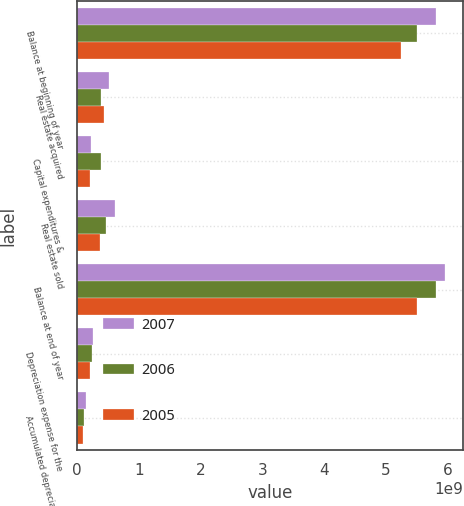<chart> <loc_0><loc_0><loc_500><loc_500><stacked_bar_chart><ecel><fcel>Balance at beginning of year<fcel>Real estate acquired<fcel>Capital expenditures &<fcel>Real estate sold<fcel>Balance at end of year<fcel>Depreciation expense for the<fcel>Accumulated depreciation on<nl><fcel>2007<fcel>5.82012e+09<fcel>5.09977e+08<fcel>2.30785e+08<fcel>6.08343e+08<fcel>5.95254e+09<fcel>2.56932e+08<fcel>1.38899e+08<nl><fcel>2006<fcel>5.51242e+09<fcel>3.92058e+08<fcel>3.79629e+08<fcel>4.6399e+08<fcel>5.82012e+09<fcel>2.43348e+08<fcel>1.13451e+08<nl><fcel>2005<fcel>5.2433e+09<fcel>4.3956e+08<fcel>2.05465e+08<fcel>3.75897e+08<fcel>5.51242e+09<fcel>2.08393e+08<fcel>9.2451e+07<nl></chart> 